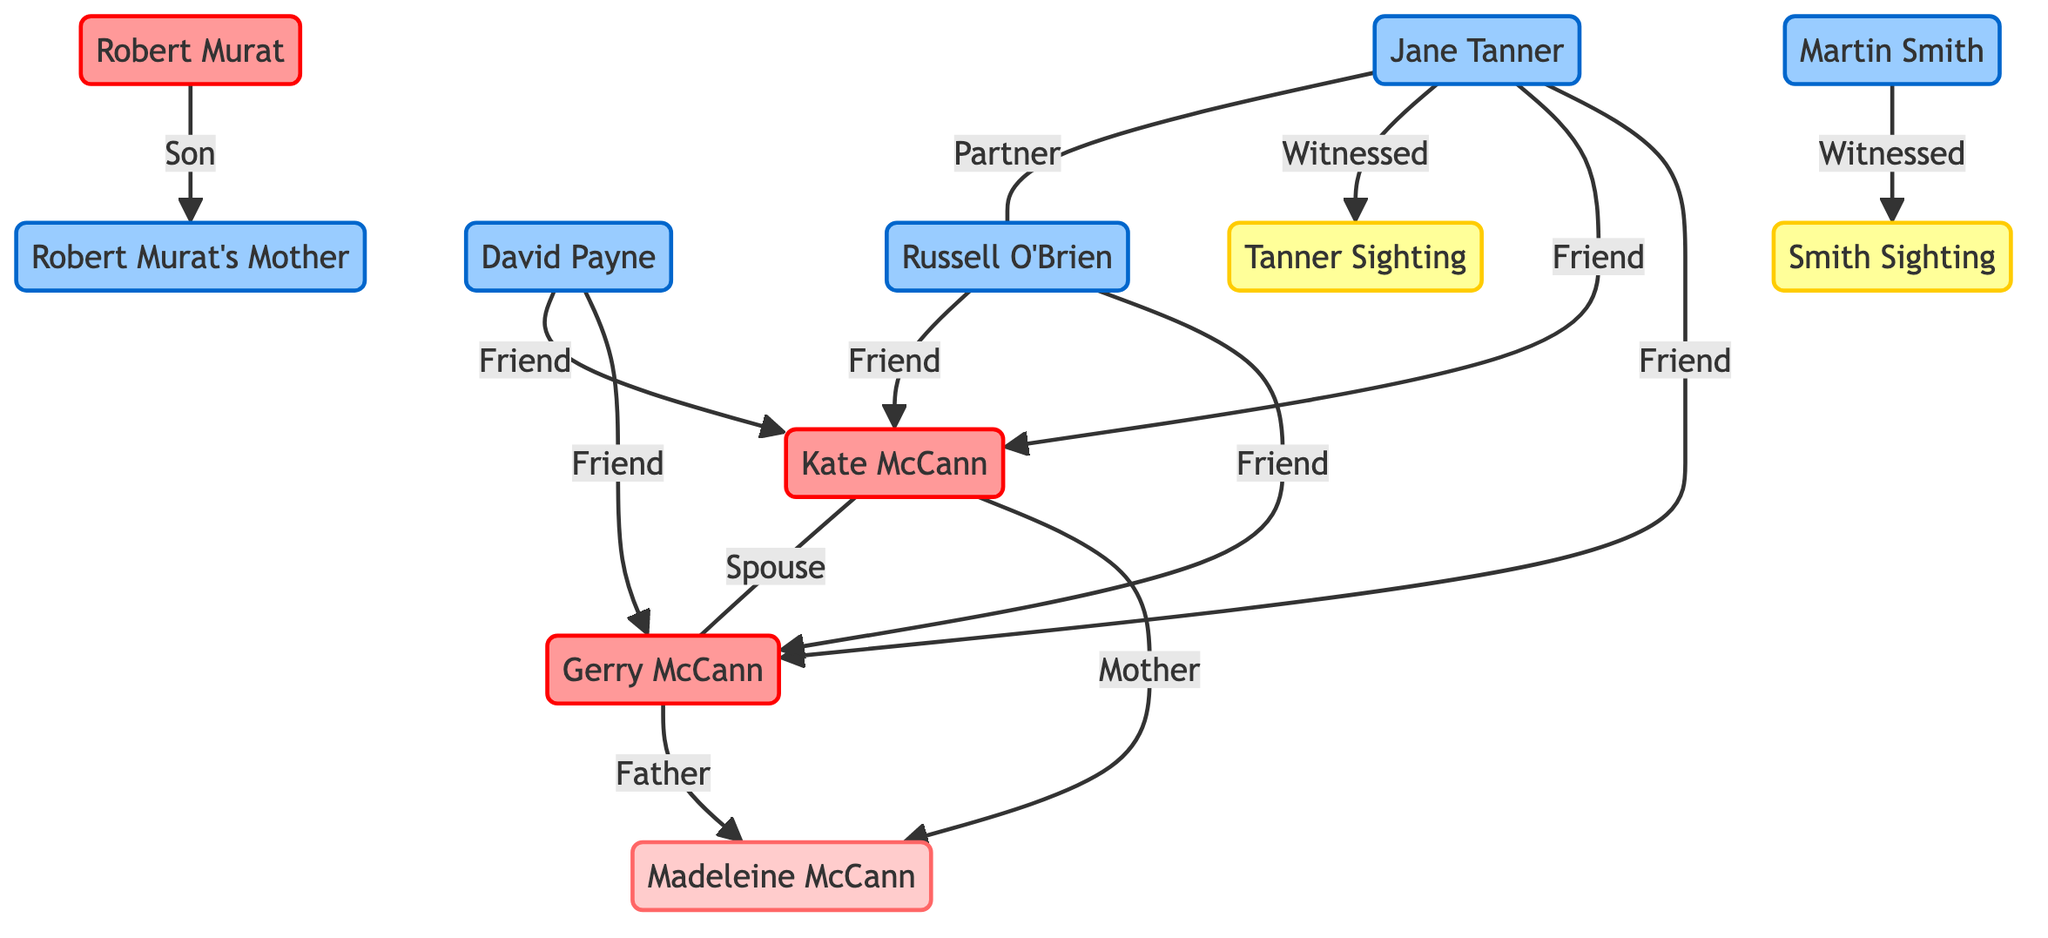What is the relationship between Kate McCann and Gerry McCann? The diagram shows that Kate McCann and Gerry McCann are connected by the relationship "Spouse." This indicates that they are married to each other.
Answer: Spouse How many friends does Jane Tanner have in the diagram? By examining the connections from Jane Tanner, I see she has three relationships labeled as "Friend" leading to Kate McCann, Gerry McCann, and Russell O'Brien. Therefore, she has three friends in total.
Answer: 3 Who is the mother of Madeleine McCann? The diagram indicates a direct relationship from Kate McCann to Madeleine McCann labeled as "Mother," making Kate McCann the mother of Madeleine McCann.
Answer: Kate McCann What type of evidence is associated with Martin Smith? The diagram provides a connection labeled "Witnessed" from Martin Smith to the "Smith Sighting," indicating that Martin Smith's contribution is characterized as a sighting witness.
Answer: Witnessed What is the relationship between Robert Murat and his mother? According to the diagram, Robert Murat is connected to his mother with the relationship labeled "Son," indicating that Robert Murat is the son of his mother.
Answer: Son How many total nodes are present in the diagram? Counting all individual entities in the nodes section reveals that there are 11 distinct nodes, including suspects, victim, witnesses, and descriptions.
Answer: 11 Which two individuals are described as partners in the diagram? The diagram shows a direct connection labeled "Partner" between Jane Tanner and Russell O'Brien, indicating their partnership.
Answer: Jane Tanner and Russell O’Brien What describes the sighting from Jane Tanner? The relationship labeled "Witnessed" shows a connection from Jane Tanner to the "Tanner Sighting," indicating that the sighting is characterized by her testimony.
Answer: Tanner Sighting Who witnessed the description tied to the name "Smith" in the diagram? The connection shows that Martin Smith is linked to the "Smith Sighting," indicating that he is the witness mentioned in that context.
Answer: Martin Smith 